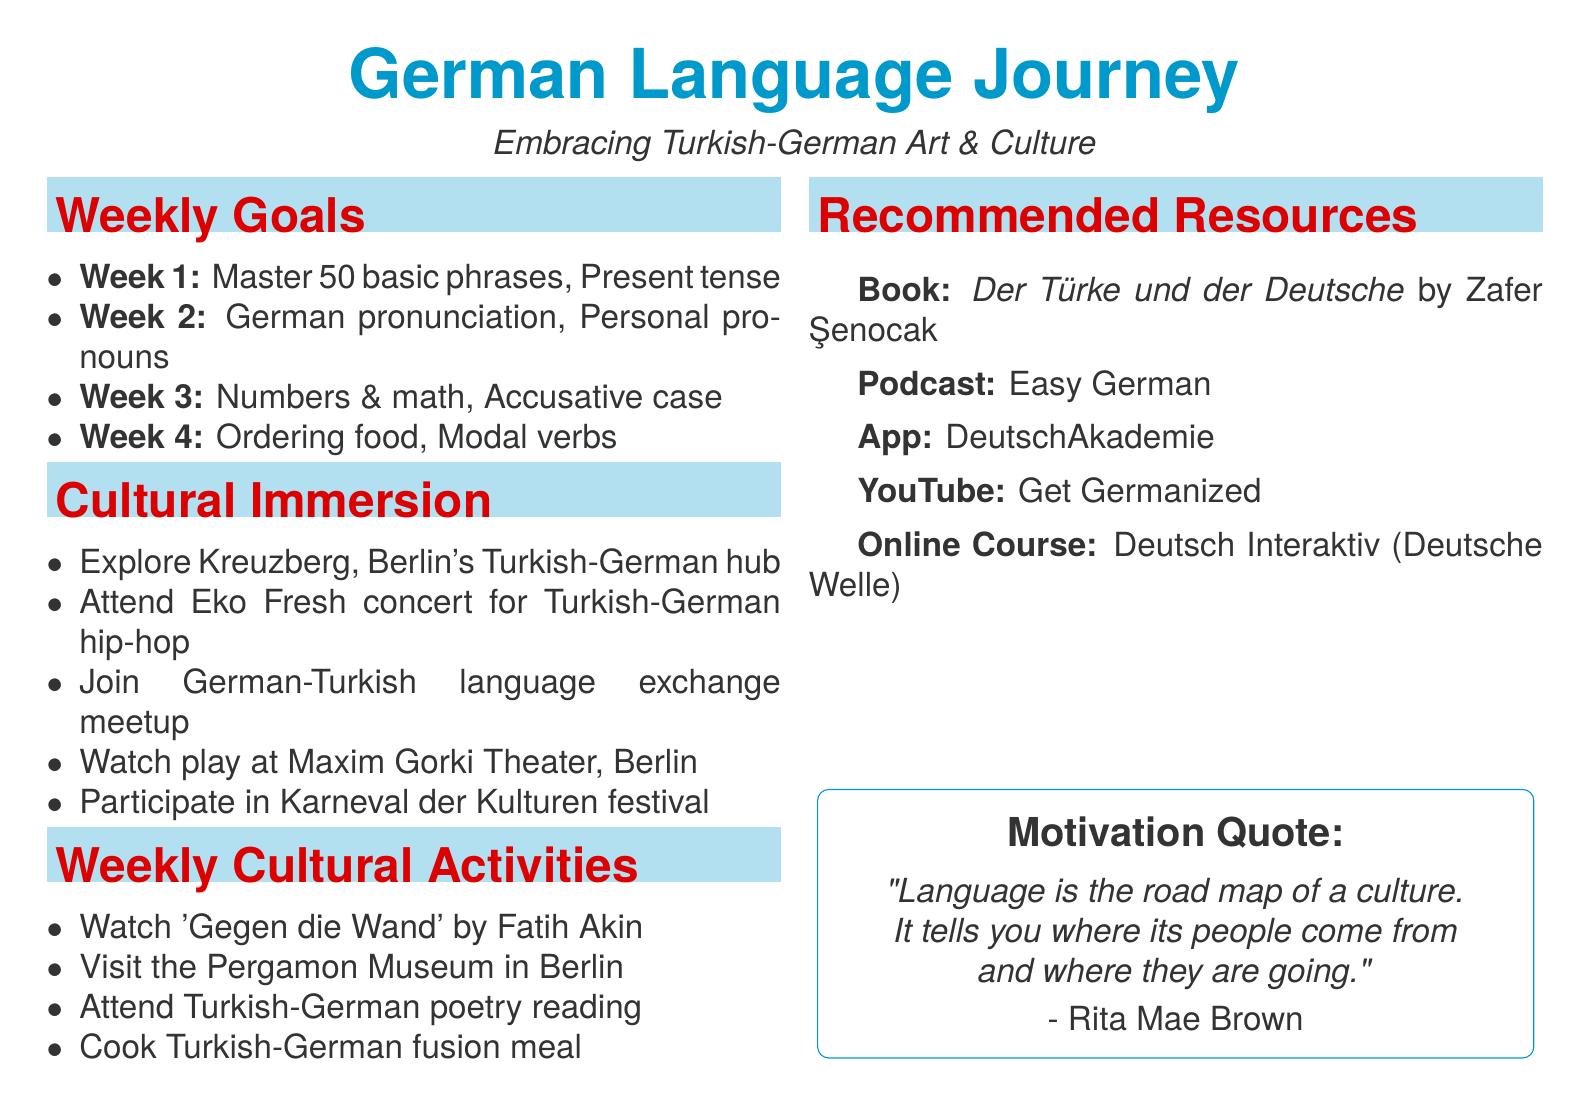What is the language goal for week 1? The language goal for week 1 is mentioned under the weekly goals section as "Master 50 basic German phrases".
Answer: Master 50 basic German phrases What cultural activity is planned for week 3? The cultural activity planned for week 3 is outlined in the weekly cultural activities as "Attend a Turkish-German poetry reading".
Answer: Attend a Turkish-German poetry reading How many weeks are covered in the study plan? The study plan covers a total of four weeks as indicated by the weekly goals listed in the document.
Answer: 4 What is the grammar focus for week 2? The grammar focus for week 2 is specified in the weekly goals as "Personal pronouns and 'sein'".
Answer: Personal pronouns and 'sein' Which museum is suggested to visit in week 2? The document suggests visiting the "Pergamon Museum in Berlin" in the cultural activities for week 2.
Answer: Pergamon Museum What type of resource is "Easy German"? The document categorizes "Easy German" as a podcast among the recommended resources section.
Answer: Podcast What is the main theme of cultural immersion activities listed? The cultural immersion activities primarily focus on experiencing the Turkish-German community and culture in various forms.
Answer: Turkish-German community and culture What is the first cultural immersion activity mentioned? The first cultural immersion activity mentioned in the document is "Visit the Kreuzberg district in Berlin".
Answer: Visit the Kreuzberg district in Berlin 